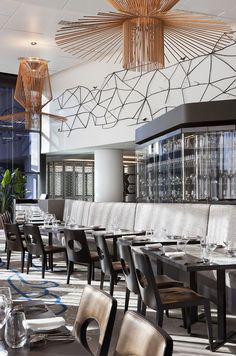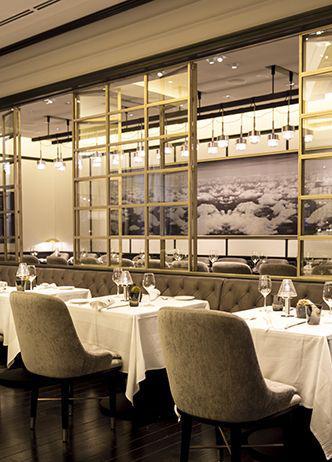The first image is the image on the left, the second image is the image on the right. Assess this claim about the two images: "There are some lighting fixtures on the rear walls, instead of just on the ceilings.". Correct or not? Answer yes or no. No. 